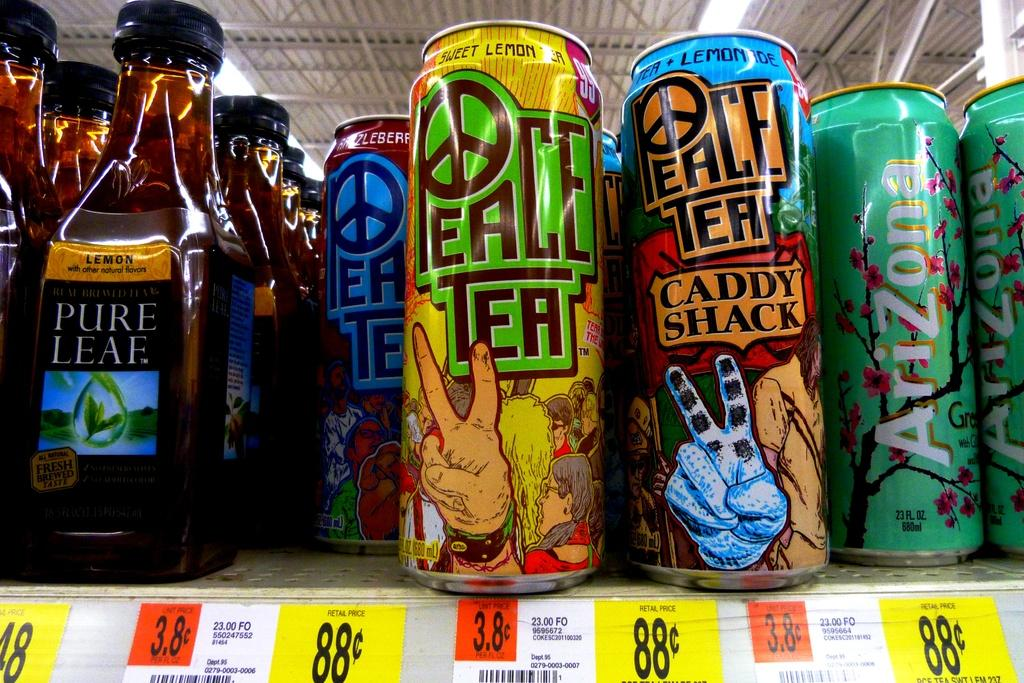<image>
Share a concise interpretation of the image provided. A selection of drinks including a brand known as Peace Tea. 